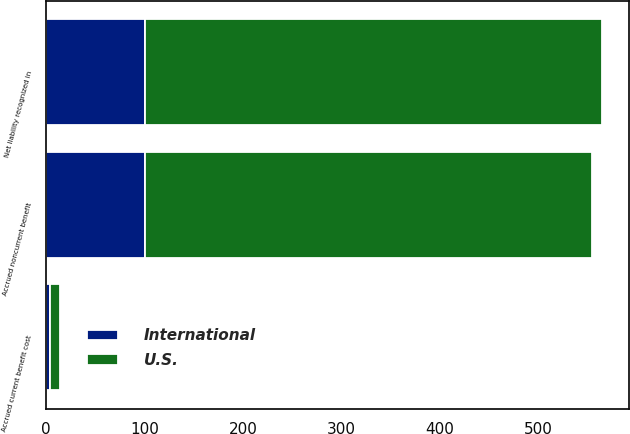Convert chart. <chart><loc_0><loc_0><loc_500><loc_500><stacked_bar_chart><ecel><fcel>Accrued current benefit cost<fcel>Accrued noncurrent benefit<fcel>Net liability recognized in<nl><fcel>U.S.<fcel>9.7<fcel>453.7<fcel>463.4<nl><fcel>International<fcel>4.4<fcel>101.1<fcel>100.7<nl></chart> 